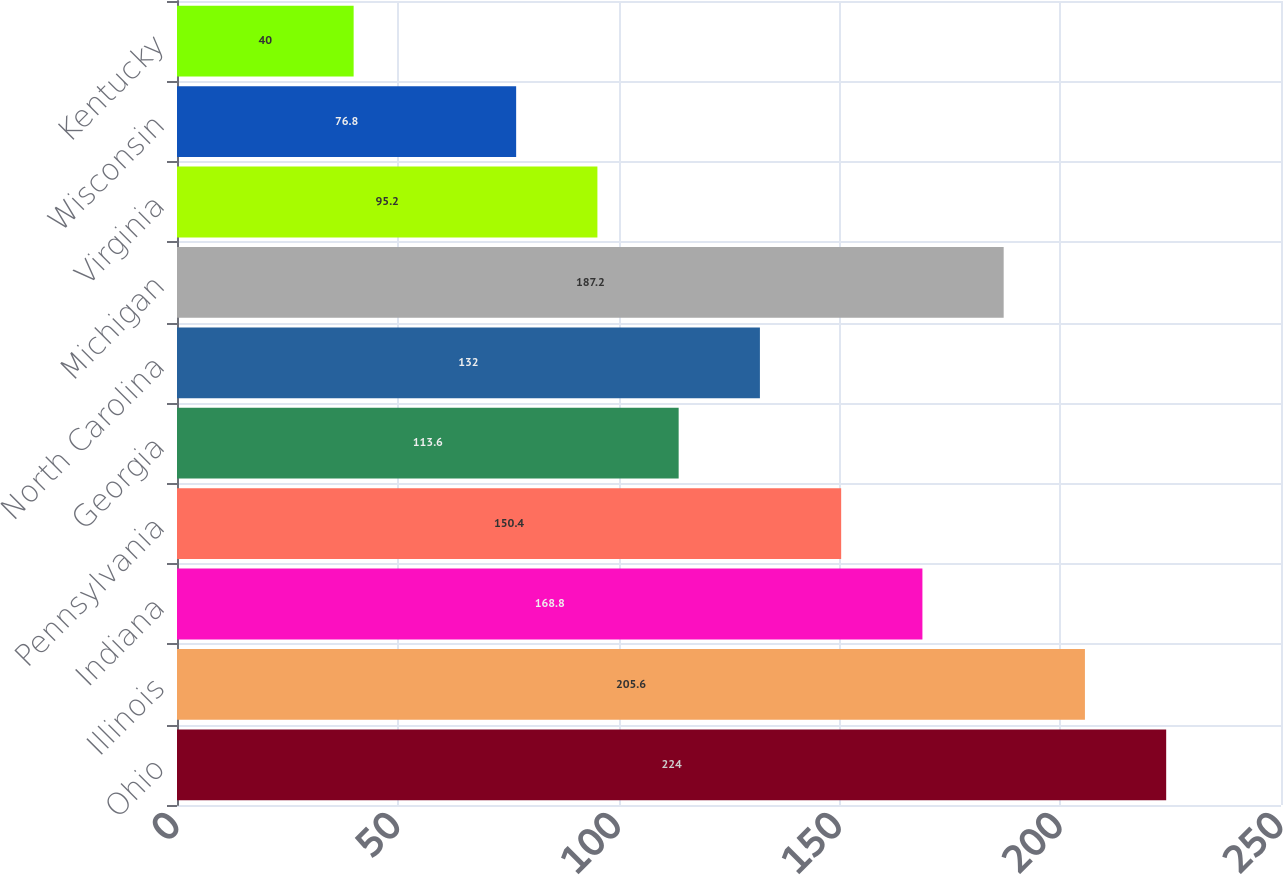Convert chart to OTSL. <chart><loc_0><loc_0><loc_500><loc_500><bar_chart><fcel>Ohio<fcel>Illinois<fcel>Indiana<fcel>Pennsylvania<fcel>Georgia<fcel>North Carolina<fcel>Michigan<fcel>Virginia<fcel>Wisconsin<fcel>Kentucky<nl><fcel>224<fcel>205.6<fcel>168.8<fcel>150.4<fcel>113.6<fcel>132<fcel>187.2<fcel>95.2<fcel>76.8<fcel>40<nl></chart> 